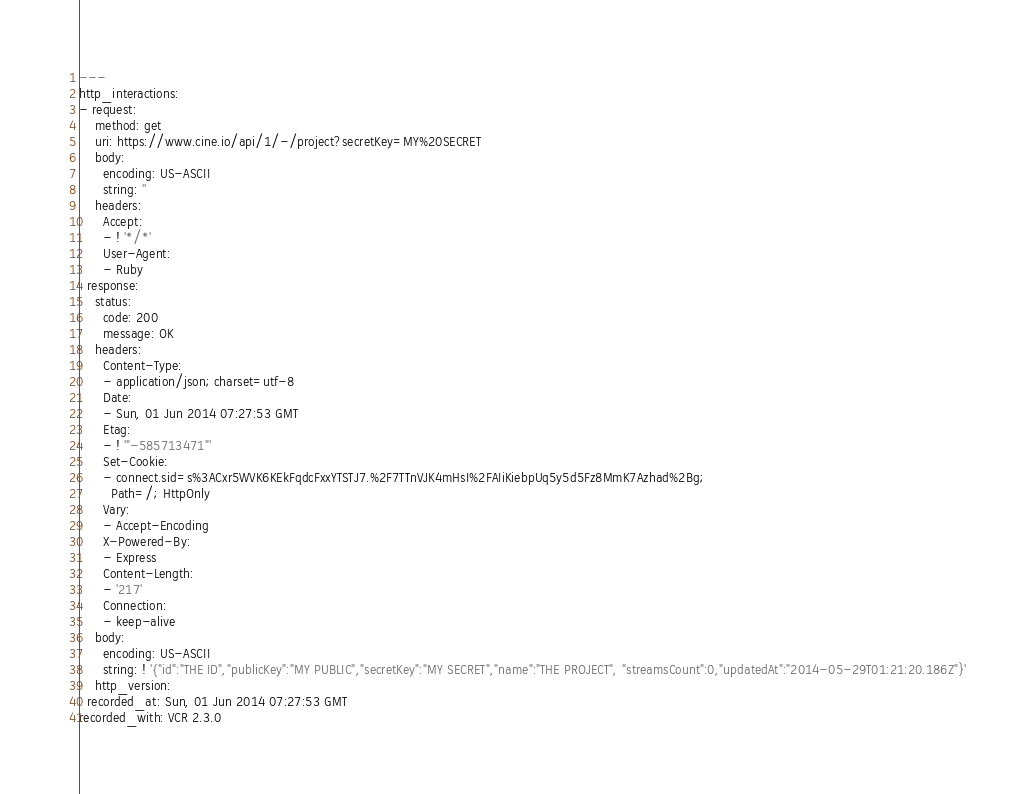Convert code to text. <code><loc_0><loc_0><loc_500><loc_500><_YAML_>---
http_interactions:
- request:
    method: get
    uri: https://www.cine.io/api/1/-/project?secretKey=MY%20SECRET
    body:
      encoding: US-ASCII
      string: ''
    headers:
      Accept:
      - ! '*/*'
      User-Agent:
      - Ruby
  response:
    status:
      code: 200
      message: OK
    headers:
      Content-Type:
      - application/json; charset=utf-8
      Date:
      - Sun, 01 Jun 2014 07:27:53 GMT
      Etag:
      - ! '"-585713471"'
      Set-Cookie:
      - connect.sid=s%3ACxr5WVK6KEkFqdcFxxYTSTJ7.%2F7TTnVJK4mHsI%2FAIiKiebpUq5y5d5Fz8MmK7Azhad%2Bg;
        Path=/; HttpOnly
      Vary:
      - Accept-Encoding
      X-Powered-By:
      - Express
      Content-Length:
      - '217'
      Connection:
      - keep-alive
    body:
      encoding: US-ASCII
      string: ! '{"id":"THE ID","publicKey":"MY PUBLIC","secretKey":"MY SECRET","name":"THE PROJECT", "streamsCount":0,"updatedAt":"2014-05-29T01:21:20.186Z"}'
    http_version:
  recorded_at: Sun, 01 Jun 2014 07:27:53 GMT
recorded_with: VCR 2.3.0
</code> 